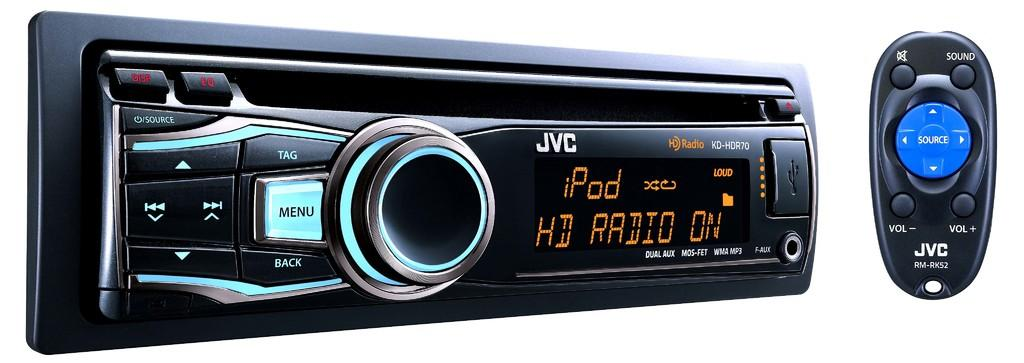<image>
Render a clear and concise summary of the photo. A JVC KD HDR70 Radio receiver with remote. 